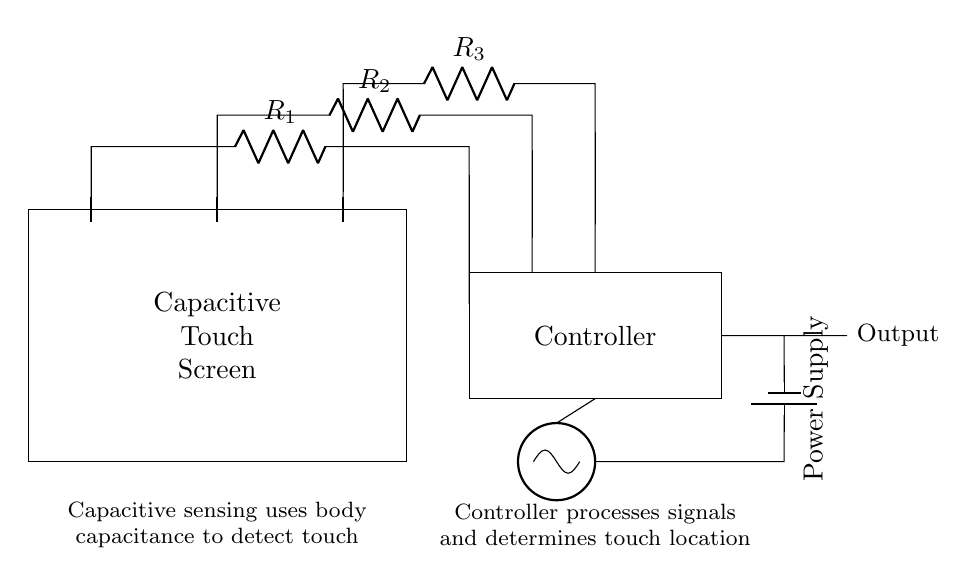What type of technology is used in this touch screen? The technology used is capacitive sensing, which detects touch based on body capacitance changes.
Answer: capacitive What are the resistors used in this circuit? The circuit has three resistors labeled R1, R2, and R3, which are connected to the sensing electrodes for touch detection.
Answer: R1, R2, R3 How many sensing electrodes are present? There are three sensing electrodes indicated in the diagram that are part of the capacitive touch screen setup.
Answer: three What is the purpose of the controller in this circuit? The controller processes the signals from the resistors to determine the location of the touch on the screen based on the capacitive readings.
Answer: signal processing What connects the power supply to the oscillator? A short wire connects the power supply to the oscillator, delivering power for its operation within the circuit.
Answer: short wire How is the output indicated in the circuit? The output is indicated as a line leading from the controller, showing where the processed result is available for further use or output.
Answer: line to output 